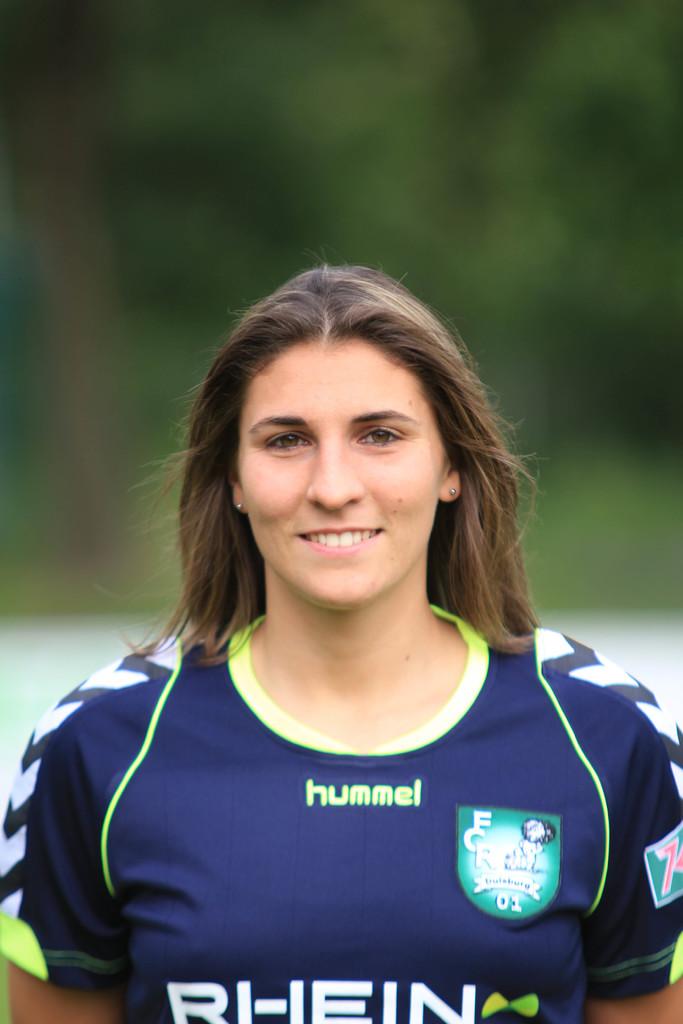What brand is the woman's jersey?
Your response must be concise. Hummel. 